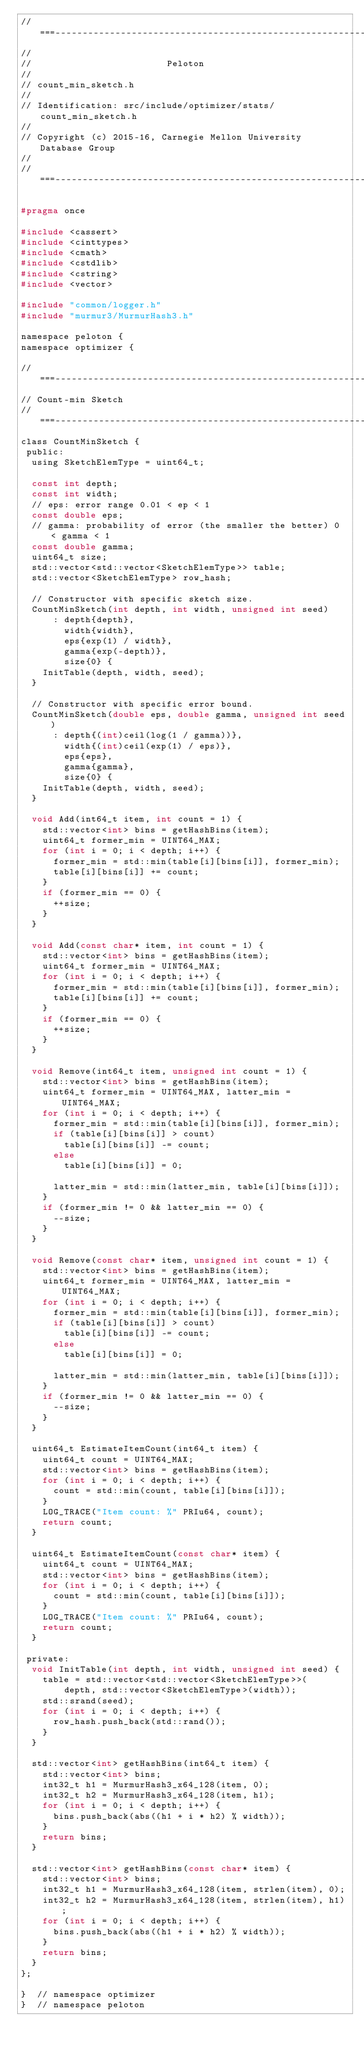<code> <loc_0><loc_0><loc_500><loc_500><_C_>//===----------------------------------------------------------------------===//
//
//                         Peloton
//
// count_min_sketch.h
//
// Identification: src/include/optimizer/stats/count_min_sketch.h
//
// Copyright (c) 2015-16, Carnegie Mellon University Database Group
//
//===----------------------------------------------------------------------===//

#pragma once

#include <cassert>
#include <cinttypes>
#include <cmath>
#include <cstdlib>
#include <cstring>
#include <vector>

#include "common/logger.h"
#include "murmur3/MurmurHash3.h"

namespace peloton {
namespace optimizer {

//===--------------------------------------------------------------------===//
// Count-min Sketch
//===--------------------------------------------------------------------===//
class CountMinSketch {
 public:
  using SketchElemType = uint64_t;

  const int depth;
  const int width;
  // eps: error range 0.01 < ep < 1
  const double eps;
  // gamma: probability of error (the smaller the better) 0 < gamma < 1
  const double gamma;
  uint64_t size;
  std::vector<std::vector<SketchElemType>> table;
  std::vector<SketchElemType> row_hash;

  // Constructor with specific sketch size.
  CountMinSketch(int depth, int width, unsigned int seed)
      : depth{depth},
        width{width},
        eps{exp(1) / width},
        gamma{exp(-depth)},
        size{0} {
    InitTable(depth, width, seed);
  }

  // Constructor with specific error bound.
  CountMinSketch(double eps, double gamma, unsigned int seed)
      : depth{(int)ceil(log(1 / gamma))},
        width{(int)ceil(exp(1) / eps)},
        eps{eps},
        gamma{gamma},
        size{0} {
    InitTable(depth, width, seed);
  }

  void Add(int64_t item, int count = 1) {
    std::vector<int> bins = getHashBins(item);
    uint64_t former_min = UINT64_MAX;
    for (int i = 0; i < depth; i++) {
      former_min = std::min(table[i][bins[i]], former_min);
      table[i][bins[i]] += count;
    }
    if (former_min == 0) {
      ++size;
    }
  }

  void Add(const char* item, int count = 1) {
    std::vector<int> bins = getHashBins(item);
    uint64_t former_min = UINT64_MAX;
    for (int i = 0; i < depth; i++) {
      former_min = std::min(table[i][bins[i]], former_min);
      table[i][bins[i]] += count;
    }
    if (former_min == 0) {
      ++size;
    }
  }

  void Remove(int64_t item, unsigned int count = 1) {
    std::vector<int> bins = getHashBins(item);
    uint64_t former_min = UINT64_MAX, latter_min = UINT64_MAX;
    for (int i = 0; i < depth; i++) {
      former_min = std::min(table[i][bins[i]], former_min);
      if (table[i][bins[i]] > count)
        table[i][bins[i]] -= count;
      else
        table[i][bins[i]] = 0;

      latter_min = std::min(latter_min, table[i][bins[i]]);
    }
    if (former_min != 0 && latter_min == 0) {
      --size;
    }
  }

  void Remove(const char* item, unsigned int count = 1) {
    std::vector<int> bins = getHashBins(item);
    uint64_t former_min = UINT64_MAX, latter_min = UINT64_MAX;
    for (int i = 0; i < depth; i++) {
      former_min = std::min(table[i][bins[i]], former_min);
      if (table[i][bins[i]] > count)
        table[i][bins[i]] -= count;
      else
        table[i][bins[i]] = 0;

      latter_min = std::min(latter_min, table[i][bins[i]]);
    }
    if (former_min != 0 && latter_min == 0) {
      --size;
    }
  }

  uint64_t EstimateItemCount(int64_t item) {
    uint64_t count = UINT64_MAX;
    std::vector<int> bins = getHashBins(item);
    for (int i = 0; i < depth; i++) {
      count = std::min(count, table[i][bins[i]]);
    }
    LOG_TRACE("Item count: %" PRIu64, count);
    return count;
  }

  uint64_t EstimateItemCount(const char* item) {
    uint64_t count = UINT64_MAX;
    std::vector<int> bins = getHashBins(item);
    for (int i = 0; i < depth; i++) {
      count = std::min(count, table[i][bins[i]]);
    }
    LOG_TRACE("Item count: %" PRIu64, count);
    return count;
  }

 private:
  void InitTable(int depth, int width, unsigned int seed) {
    table = std::vector<std::vector<SketchElemType>>(
        depth, std::vector<SketchElemType>(width));
    std::srand(seed);
    for (int i = 0; i < depth; i++) {
      row_hash.push_back(std::rand());
    }
  }

  std::vector<int> getHashBins(int64_t item) {
    std::vector<int> bins;
    int32_t h1 = MurmurHash3_x64_128(item, 0);
    int32_t h2 = MurmurHash3_x64_128(item, h1);
    for (int i = 0; i < depth; i++) {
      bins.push_back(abs((h1 + i * h2) % width));
    }
    return bins;
  }

  std::vector<int> getHashBins(const char* item) {
    std::vector<int> bins;
    int32_t h1 = MurmurHash3_x64_128(item, strlen(item), 0);
    int32_t h2 = MurmurHash3_x64_128(item, strlen(item), h1);
    for (int i = 0; i < depth; i++) {
      bins.push_back(abs((h1 + i * h2) % width));
    }
    return bins;
  }
};

}  // namespace optimizer
}  // namespace peloton
</code> 